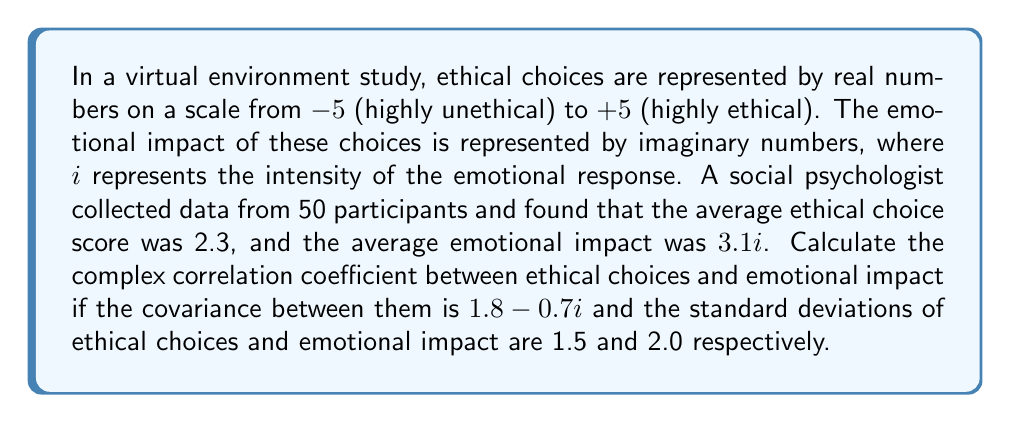Help me with this question. To calculate the complex correlation coefficient, we'll use the formula:

$$\rho = \frac{\text{Cov}(X,Y)}{\sigma_X \sigma_Y}$$

Where:
- $\text{Cov}(X,Y)$ is the covariance between X (ethical choices) and Y (emotional impact)
- $\sigma_X$ is the standard deviation of X
- $\sigma_Y$ is the standard deviation of Y

Given:
- $\text{Cov}(X,Y) = 1.8 - 0.7i$
- $\sigma_X = 1.5$
- $\sigma_Y = 2.0$

Step 1: Substitute the values into the formula:

$$\rho = \frac{1.8 - 0.7i}{1.5 \cdot 2.0}$$

Step 2: Simplify the denominator:

$$\rho = \frac{1.8 - 0.7i}{3.0}$$

Step 3: Divide both the real and imaginary parts by 3.0:

$$\rho = \frac{1.8}{3.0} - \frac{0.7}{3.0}i$$

Step 4: Simplify:

$$\rho = 0.6 - 0.233i$$

This complex correlation coefficient can be interpreted as follows:
- The real part (0.6) indicates a moderate positive correlation between ethical choices and the magnitude of emotional impact.
- The imaginary part (-0.233i) suggests a weak negative correlation between ethical choices and the phase or direction of emotional impact.
Answer: $\rho = 0.6 - 0.233i$ 